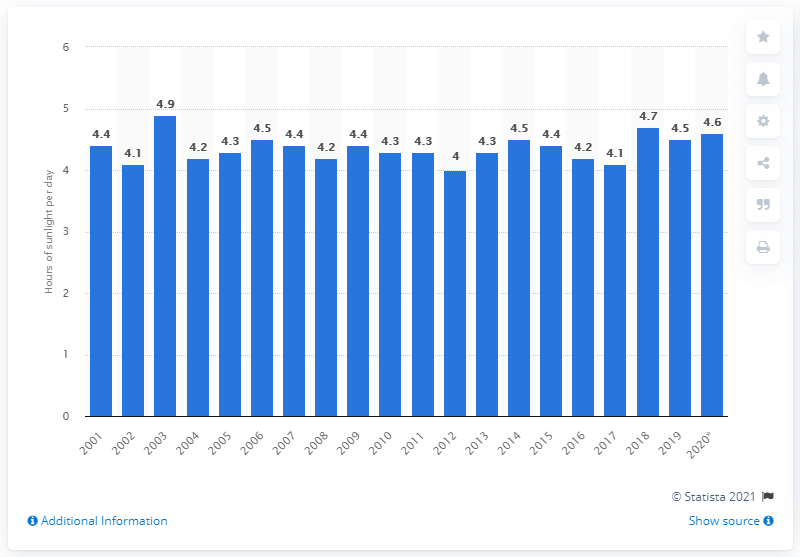Highlight a few significant elements in this photo. In 2018, the average daily sun hours in the UK was 4.7 hours. 